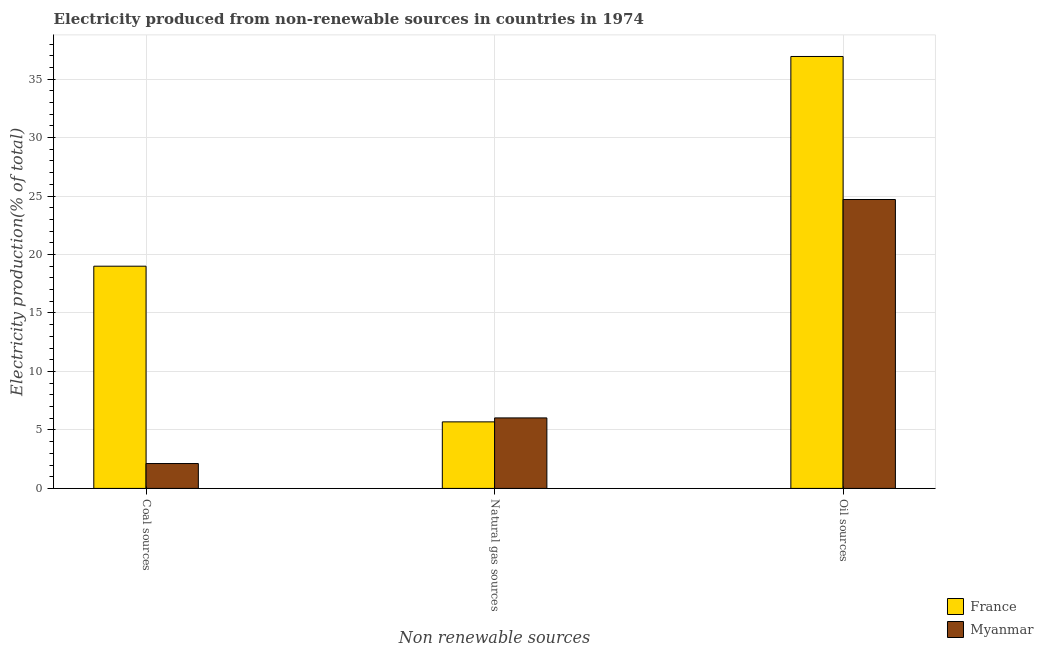How many groups of bars are there?
Your answer should be compact. 3. Are the number of bars on each tick of the X-axis equal?
Your response must be concise. Yes. How many bars are there on the 1st tick from the left?
Give a very brief answer. 2. How many bars are there on the 2nd tick from the right?
Your answer should be very brief. 2. What is the label of the 3rd group of bars from the left?
Provide a succinct answer. Oil sources. What is the percentage of electricity produced by coal in Myanmar?
Ensure brevity in your answer.  2.13. Across all countries, what is the maximum percentage of electricity produced by coal?
Your response must be concise. 19. Across all countries, what is the minimum percentage of electricity produced by coal?
Your answer should be very brief. 2.13. In which country was the percentage of electricity produced by natural gas maximum?
Provide a short and direct response. Myanmar. In which country was the percentage of electricity produced by natural gas minimum?
Provide a short and direct response. France. What is the total percentage of electricity produced by coal in the graph?
Ensure brevity in your answer.  21.13. What is the difference between the percentage of electricity produced by coal in France and that in Myanmar?
Provide a succinct answer. 16.87. What is the difference between the percentage of electricity produced by natural gas in Myanmar and the percentage of electricity produced by oil sources in France?
Offer a terse response. -30.91. What is the average percentage of electricity produced by coal per country?
Provide a succinct answer. 10.56. What is the difference between the percentage of electricity produced by natural gas and percentage of electricity produced by oil sources in France?
Your response must be concise. -31.24. What is the ratio of the percentage of electricity produced by oil sources in Myanmar to that in France?
Offer a terse response. 0.67. Is the difference between the percentage of electricity produced by coal in France and Myanmar greater than the difference between the percentage of electricity produced by natural gas in France and Myanmar?
Keep it short and to the point. Yes. What is the difference between the highest and the second highest percentage of electricity produced by natural gas?
Provide a succinct answer. 0.34. What is the difference between the highest and the lowest percentage of electricity produced by natural gas?
Your answer should be compact. 0.34. In how many countries, is the percentage of electricity produced by natural gas greater than the average percentage of electricity produced by natural gas taken over all countries?
Your response must be concise. 1. Is the sum of the percentage of electricity produced by coal in Myanmar and France greater than the maximum percentage of electricity produced by oil sources across all countries?
Your answer should be compact. No. What does the 1st bar from the left in Oil sources represents?
Your answer should be compact. France. What does the 1st bar from the right in Coal sources represents?
Make the answer very short. Myanmar. Are all the bars in the graph horizontal?
Keep it short and to the point. No. Are the values on the major ticks of Y-axis written in scientific E-notation?
Your answer should be very brief. No. Does the graph contain grids?
Your answer should be very brief. Yes. How many legend labels are there?
Provide a succinct answer. 2. How are the legend labels stacked?
Your answer should be compact. Vertical. What is the title of the graph?
Offer a very short reply. Electricity produced from non-renewable sources in countries in 1974. Does "Other small states" appear as one of the legend labels in the graph?
Your answer should be very brief. No. What is the label or title of the X-axis?
Offer a terse response. Non renewable sources. What is the Electricity production(% of total) in France in Coal sources?
Your answer should be compact. 19. What is the Electricity production(% of total) in Myanmar in Coal sources?
Provide a short and direct response. 2.13. What is the Electricity production(% of total) of France in Natural gas sources?
Your answer should be compact. 5.69. What is the Electricity production(% of total) in Myanmar in Natural gas sources?
Provide a short and direct response. 6.03. What is the Electricity production(% of total) of France in Oil sources?
Offer a very short reply. 36.94. What is the Electricity production(% of total) of Myanmar in Oil sources?
Offer a terse response. 24.7. Across all Non renewable sources, what is the maximum Electricity production(% of total) of France?
Your answer should be very brief. 36.94. Across all Non renewable sources, what is the maximum Electricity production(% of total) of Myanmar?
Your answer should be compact. 24.7. Across all Non renewable sources, what is the minimum Electricity production(% of total) in France?
Your answer should be very brief. 5.69. Across all Non renewable sources, what is the minimum Electricity production(% of total) of Myanmar?
Keep it short and to the point. 2.13. What is the total Electricity production(% of total) in France in the graph?
Your answer should be very brief. 61.63. What is the total Electricity production(% of total) in Myanmar in the graph?
Your answer should be very brief. 32.86. What is the difference between the Electricity production(% of total) in France in Coal sources and that in Natural gas sources?
Your answer should be compact. 13.31. What is the difference between the Electricity production(% of total) in Myanmar in Coal sources and that in Natural gas sources?
Provide a succinct answer. -3.9. What is the difference between the Electricity production(% of total) in France in Coal sources and that in Oil sources?
Provide a succinct answer. -17.93. What is the difference between the Electricity production(% of total) of Myanmar in Coal sources and that in Oil sources?
Your answer should be very brief. -22.58. What is the difference between the Electricity production(% of total) of France in Natural gas sources and that in Oil sources?
Your answer should be very brief. -31.24. What is the difference between the Electricity production(% of total) in Myanmar in Natural gas sources and that in Oil sources?
Provide a succinct answer. -18.68. What is the difference between the Electricity production(% of total) of France in Coal sources and the Electricity production(% of total) of Myanmar in Natural gas sources?
Your answer should be very brief. 12.97. What is the difference between the Electricity production(% of total) of France in Coal sources and the Electricity production(% of total) of Myanmar in Oil sources?
Make the answer very short. -5.7. What is the difference between the Electricity production(% of total) in France in Natural gas sources and the Electricity production(% of total) in Myanmar in Oil sources?
Make the answer very short. -19.01. What is the average Electricity production(% of total) of France per Non renewable sources?
Offer a terse response. 20.54. What is the average Electricity production(% of total) in Myanmar per Non renewable sources?
Provide a short and direct response. 10.95. What is the difference between the Electricity production(% of total) in France and Electricity production(% of total) in Myanmar in Coal sources?
Your response must be concise. 16.87. What is the difference between the Electricity production(% of total) of France and Electricity production(% of total) of Myanmar in Natural gas sources?
Your answer should be compact. -0.34. What is the difference between the Electricity production(% of total) in France and Electricity production(% of total) in Myanmar in Oil sources?
Make the answer very short. 12.23. What is the ratio of the Electricity production(% of total) of France in Coal sources to that in Natural gas sources?
Keep it short and to the point. 3.34. What is the ratio of the Electricity production(% of total) in Myanmar in Coal sources to that in Natural gas sources?
Provide a succinct answer. 0.35. What is the ratio of the Electricity production(% of total) in France in Coal sources to that in Oil sources?
Offer a terse response. 0.51. What is the ratio of the Electricity production(% of total) in Myanmar in Coal sources to that in Oil sources?
Your answer should be very brief. 0.09. What is the ratio of the Electricity production(% of total) in France in Natural gas sources to that in Oil sources?
Provide a short and direct response. 0.15. What is the ratio of the Electricity production(% of total) in Myanmar in Natural gas sources to that in Oil sources?
Make the answer very short. 0.24. What is the difference between the highest and the second highest Electricity production(% of total) in France?
Your answer should be compact. 17.93. What is the difference between the highest and the second highest Electricity production(% of total) of Myanmar?
Your answer should be very brief. 18.68. What is the difference between the highest and the lowest Electricity production(% of total) in France?
Offer a very short reply. 31.24. What is the difference between the highest and the lowest Electricity production(% of total) in Myanmar?
Your answer should be very brief. 22.58. 